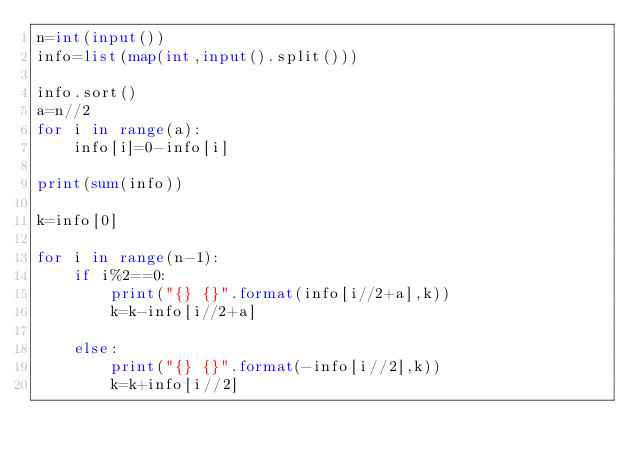<code> <loc_0><loc_0><loc_500><loc_500><_Python_>n=int(input())
info=list(map(int,input().split()))

info.sort()
a=n//2
for i in range(a):
    info[i]=0-info[i]
    
print(sum(info))

k=info[0]

for i in range(n-1):
    if i%2==0:
        print("{} {}".format(info[i//2+a],k))
        k=k-info[i//2+a]
        
    else:
        print("{} {}".format(-info[i//2],k))
        k=k+info[i//2]</code> 